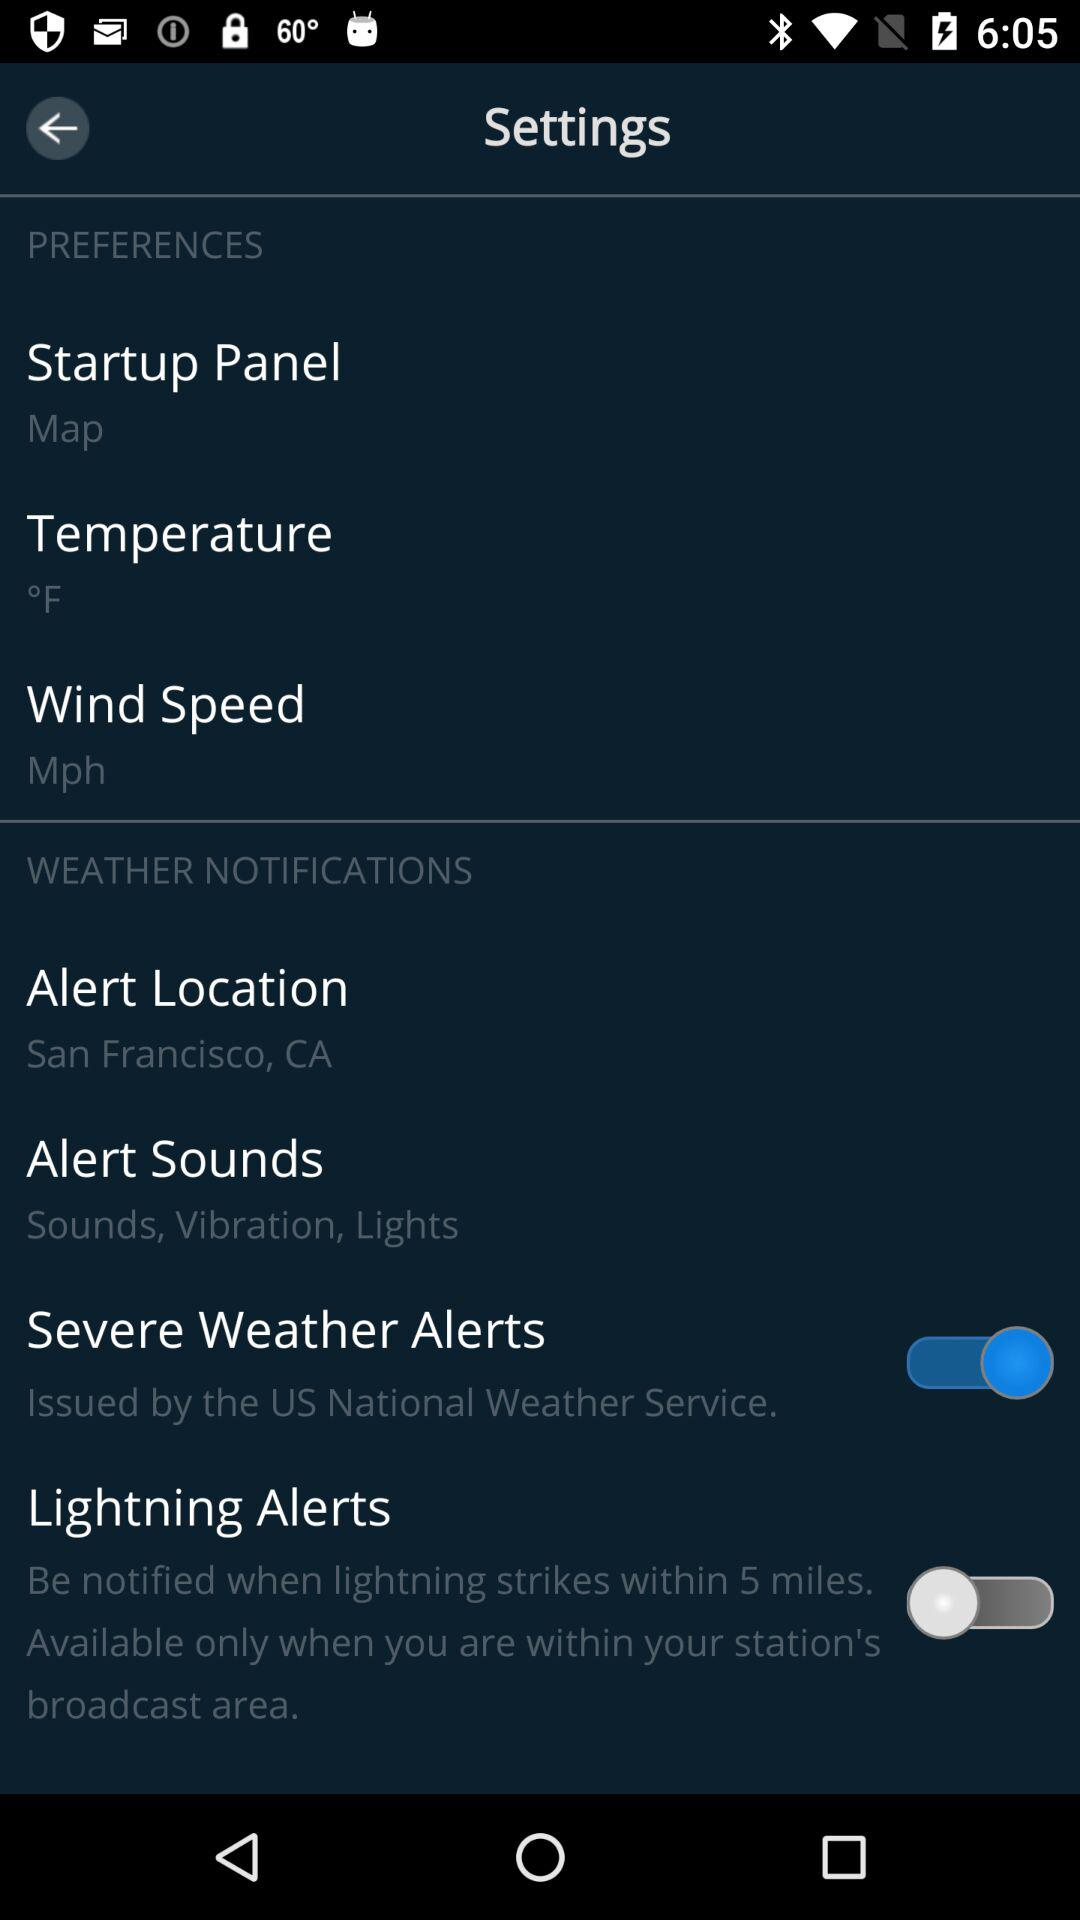How many items in the Weather Notifications section have a switch?
Answer the question using a single word or phrase. 2 